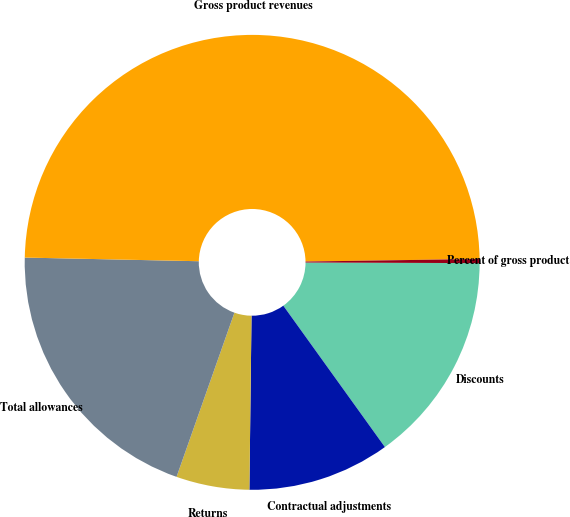Convert chart. <chart><loc_0><loc_0><loc_500><loc_500><pie_chart><fcel>Discounts<fcel>Contractual adjustments<fcel>Returns<fcel>Total allowances<fcel>Gross product revenues<fcel>Percent of gross product<nl><fcel>15.03%<fcel>10.11%<fcel>5.2%<fcel>19.94%<fcel>49.43%<fcel>0.29%<nl></chart> 